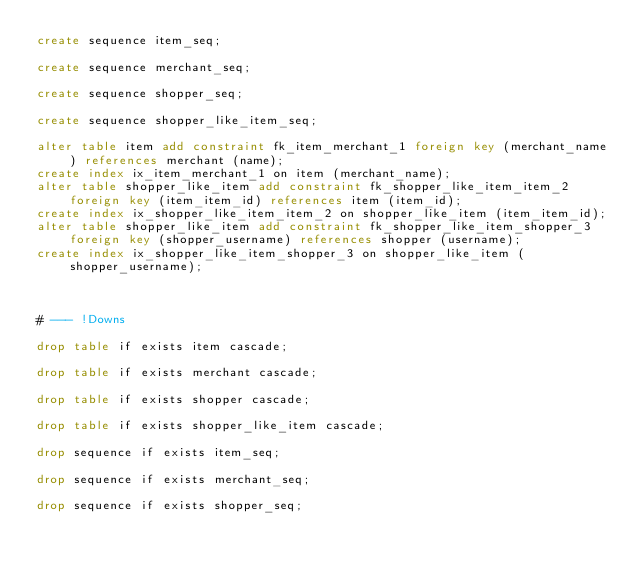<code> <loc_0><loc_0><loc_500><loc_500><_SQL_>create sequence item_seq;

create sequence merchant_seq;

create sequence shopper_seq;

create sequence shopper_like_item_seq;

alter table item add constraint fk_item_merchant_1 foreign key (merchant_name) references merchant (name);
create index ix_item_merchant_1 on item (merchant_name);
alter table shopper_like_item add constraint fk_shopper_like_item_item_2 foreign key (item_item_id) references item (item_id);
create index ix_shopper_like_item_item_2 on shopper_like_item (item_item_id);
alter table shopper_like_item add constraint fk_shopper_like_item_shopper_3 foreign key (shopper_username) references shopper (username);
create index ix_shopper_like_item_shopper_3 on shopper_like_item (shopper_username);



# --- !Downs

drop table if exists item cascade;

drop table if exists merchant cascade;

drop table if exists shopper cascade;

drop table if exists shopper_like_item cascade;

drop sequence if exists item_seq;

drop sequence if exists merchant_seq;

drop sequence if exists shopper_seq;
</code> 